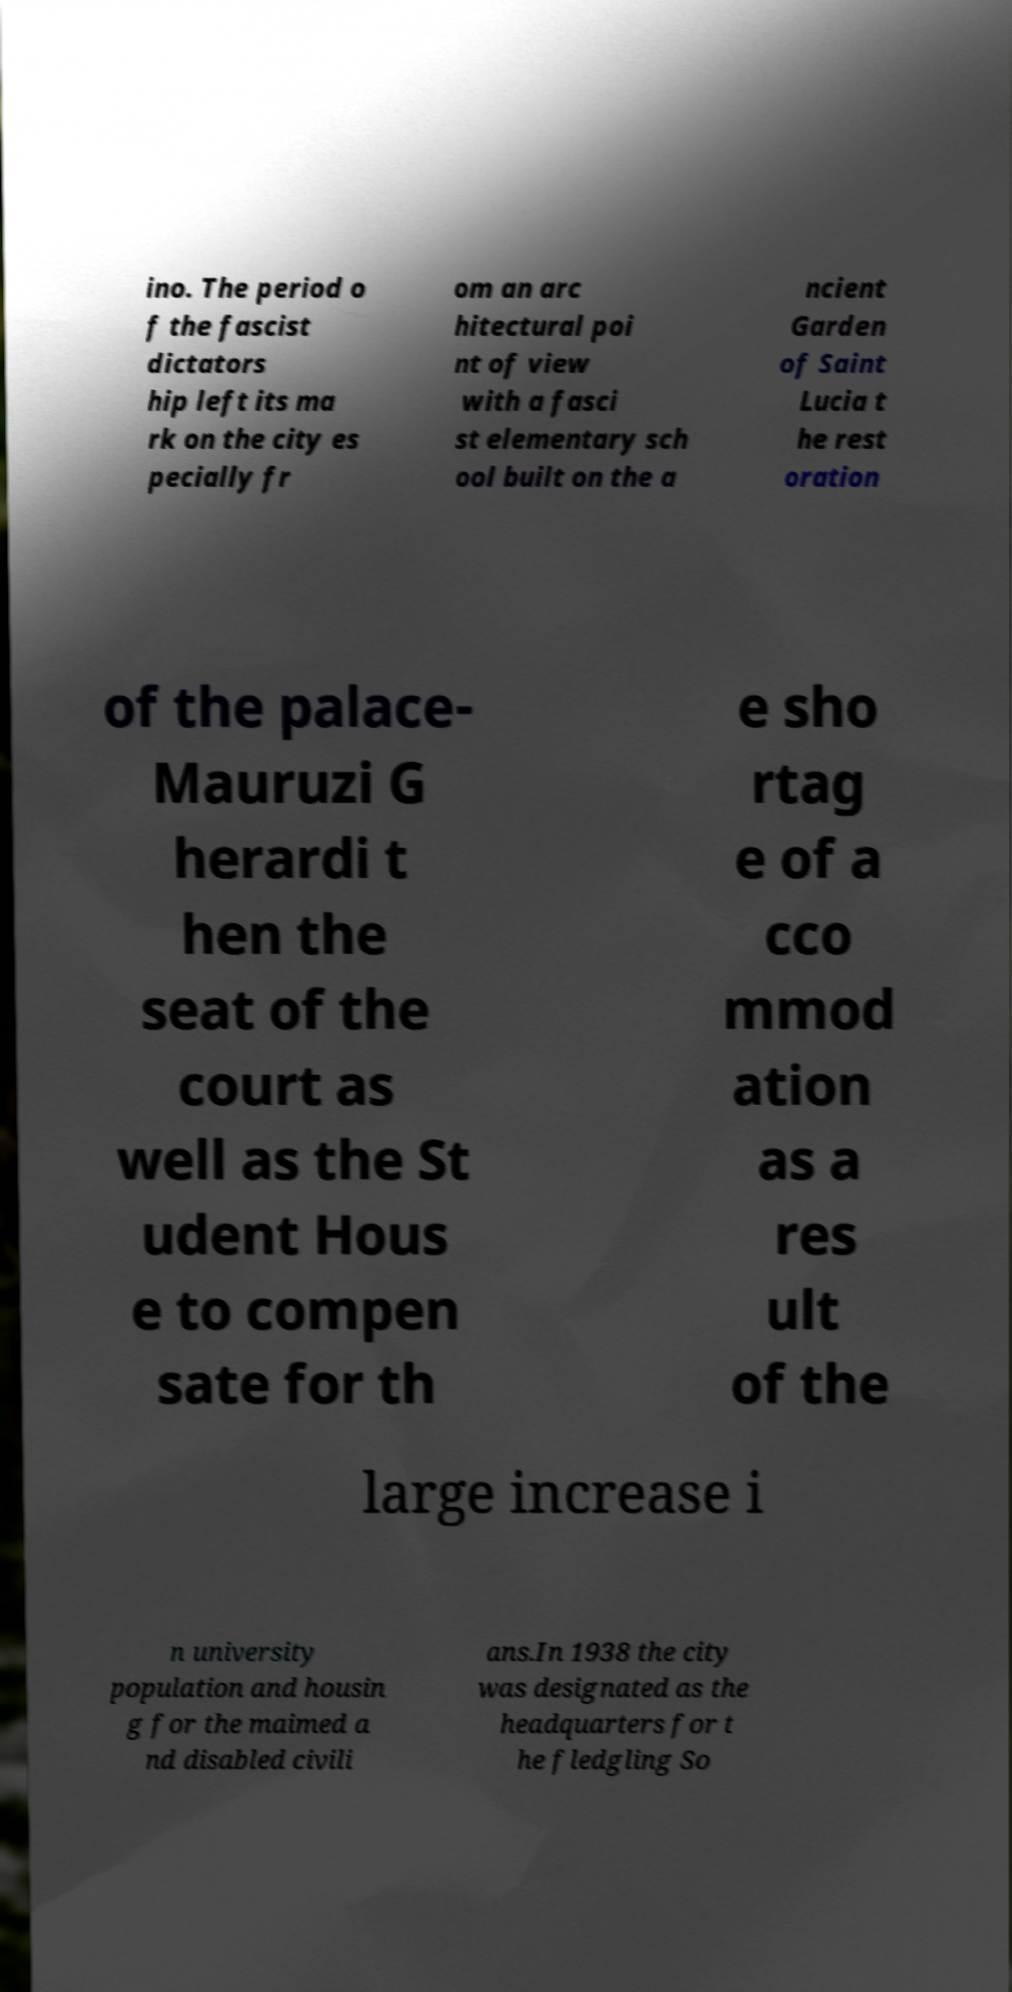I need the written content from this picture converted into text. Can you do that? ino. The period o f the fascist dictators hip left its ma rk on the city es pecially fr om an arc hitectural poi nt of view with a fasci st elementary sch ool built on the a ncient Garden of Saint Lucia t he rest oration of the palace- Mauruzi G herardi t hen the seat of the court as well as the St udent Hous e to compen sate for th e sho rtag e of a cco mmod ation as a res ult of the large increase i n university population and housin g for the maimed a nd disabled civili ans.In 1938 the city was designated as the headquarters for t he fledgling So 